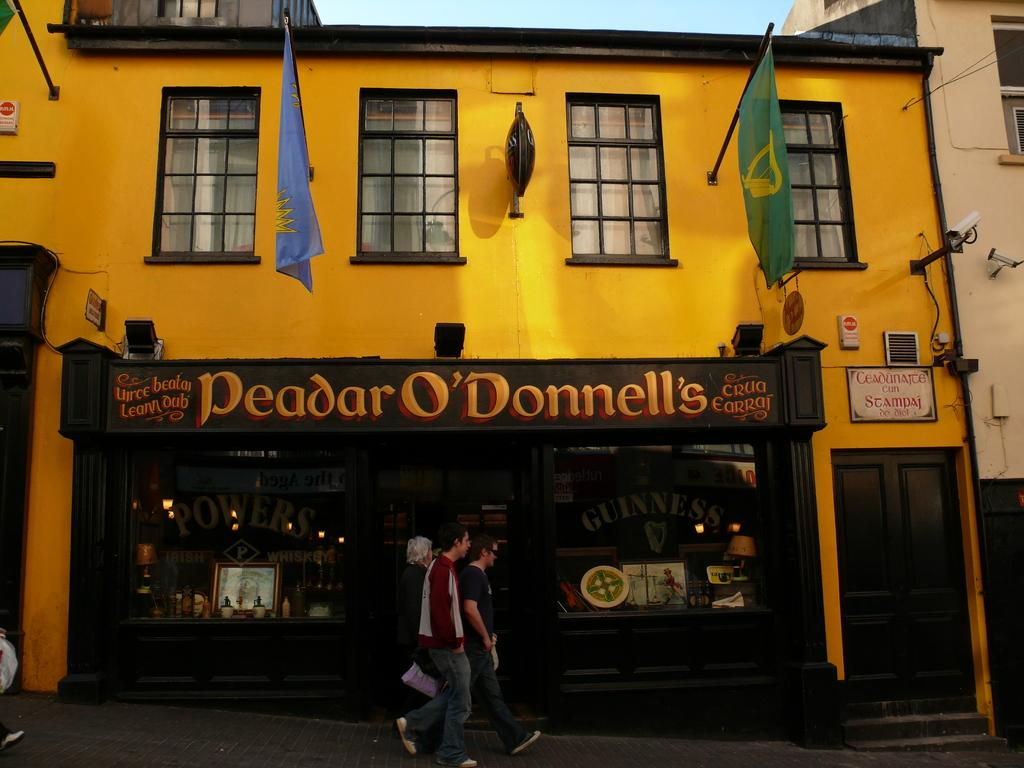What are the people in the image doing? The people in the image are walking. What type of structures can be seen in the image? There are buildings in the image. What are the flags in the image attached to? The flags in the image are attached to sticks. What architectural feature is visible in the image? There are windows in the image. What objects are present in the image that might be used for displaying information? There are boards in the image. What devices are visible in the image that might be used for recording or capturing images? There are cameras in the image. What material is present in the image that might be used for protection or transparency? There is glass in the image. What can be seen in the background of the image? The sky is visible in the background of the image. What is the son's favorite color in the image? There is no mention of a son or a favorite color in the image. How many people are answering questions in the image? There is no indication that anyone is answering questions in the image. 